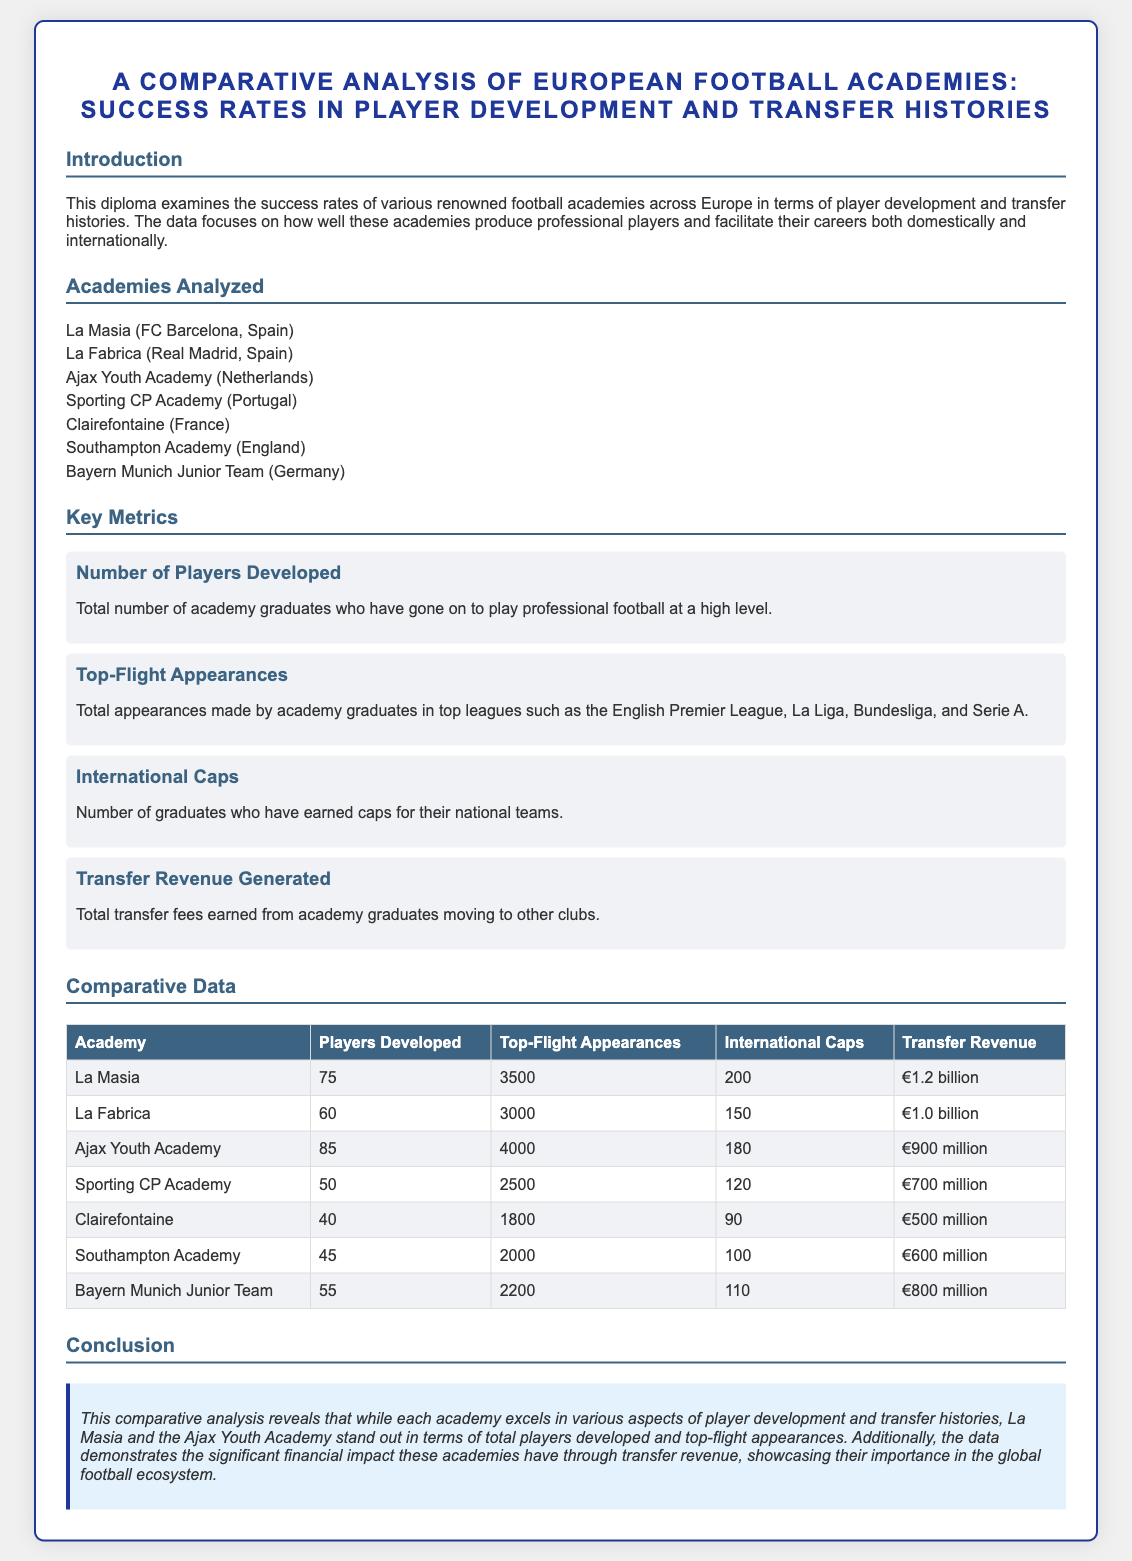What is the title of the diploma? The title is provided at the beginning of the document and outlines the main focus of the analysis.
Answer: A Comparative Analysis of European Football Academies: Success Rates in Player Development and Transfer Histories How many players did Ajax Youth Academy develop? The number of players developed by each academy is listed in the comparative data table.
Answer: 85 What is the transfer revenue for La Masia? The transfer revenue for each academy is detailed in the comparative data table.
Answer: €1.2 billion Which academy had the least top-flight appearances? The total top-flight appearances for each academy are compared in the document's table, allowing for this determination.
Answer: Clairefontaine How many international caps did graduates from La Fabrica receive? The number of international caps is a metric listed for each academy in the comparative data.
Answer: 150 Which two academies excel in player development? The conclusion summarizes the performance of the academies based on the examined metrics.
Answer: La Masia and Ajax Youth Academy What is the focus of the diploma? The introduction section provides information about what the diploma aims to analyze and its scope.
Answer: Player development and transfer histories What is the total number of players developed by Southampton Academy? The document lists the number of players developed by each academy in a comparative table.
Answer: 45 What color is used for the background of the document? The color used for the body background of the document can be found in the CSS style section.
Answer: Light gray 